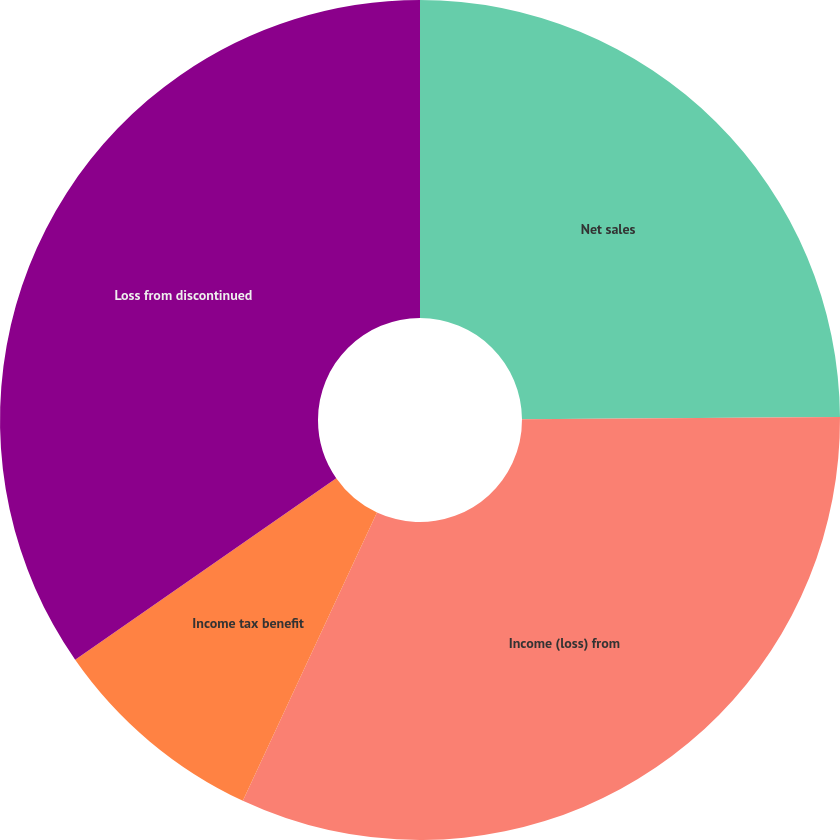<chart> <loc_0><loc_0><loc_500><loc_500><pie_chart><fcel>Net sales<fcel>Income (loss) from<fcel>Income tax benefit<fcel>Loss from discontinued<nl><fcel>24.89%<fcel>32.04%<fcel>8.4%<fcel>34.67%<nl></chart> 